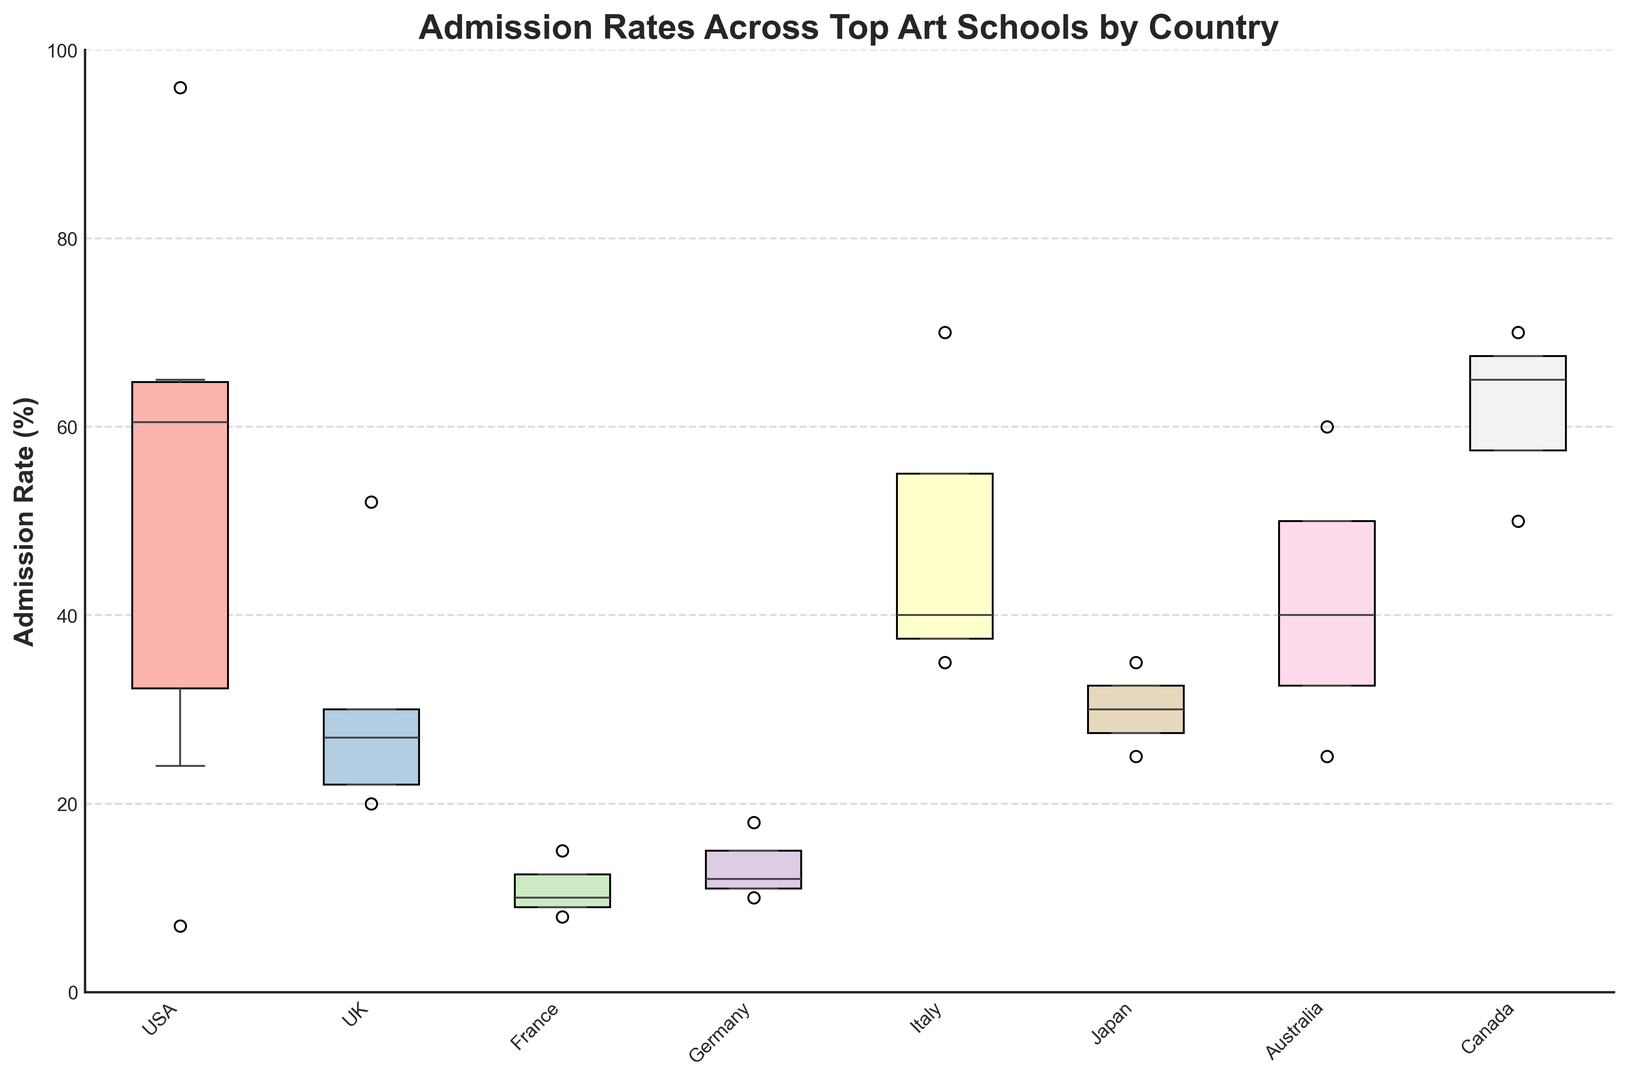What country has the school with the lowest admission rate? The box plot shows the median, quartiles, and outliers of the admission rates, but we're interested in the single lowest value, which would be an outlier in one of the countries' box plots. The USA has Yale University School of Art with an admission rate of 7%, which appears to be the lowest.
Answer: USA Which country has the highest overall range of admission rates? The range is the difference between the maximum and minimum values within a country's box plot. By visually inspecting the box plots, we compare the lengths of the whiskers. The USA demonstrates the widest range as it has schools like Parsons School of Design at 65% and Yale University School of Art at 7%.
Answer: USA Which country has the smallest median admission rate? To determine this, we look at the line inside each box, which represents the median. By comparing these lines, France has the smallest median admission rate.
Answer: France Are there any countries where all the schools have an admission rate below 50%? We check the upper boundary (the top whisker) of each box plot to see if it lies below the 50% mark. In France and Germany, all schools have admission rates below 50%.
Answer: France and Germany Which country has the highest median admission rate? To determine this, look for the highest position of the middle line within each box. Canada has the highest median admission rate, with the median near the 60% mark.
Answer: Canada Which country has more variability in admission rates, France or Germany? Variability can be assessed by comparing the interquartile ranges (IQR) and the spread (range from minimum to maximum shown by whiskers) of the box plots from both countries. France shows a higher variability as its range and IQR (between the 25th and 75th percentiles) are larger.
Answer: France Compare the median admission rates of art schools in Japan and Australia. Which country has higher median admission rates? Looking at the box plots, particularly the median lines inside each box, Australia has slightly higher medians compared to Japan, indicating that Australian art schools on average have a higher admission rate.
Answer: Australia Which country’s schools have the broadest spread in terms of admission rates from the 25th to the 75th percentile? The interquartile range (IQR) is the distance between the 25th percentile (bottom of the box) and the 75th percentile (top of the box). Visually, the USA has the broadest spread between these percentiles.
Answer: USA 